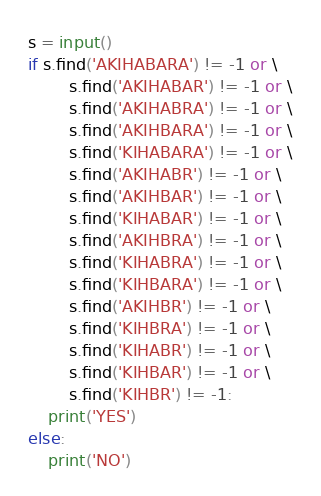<code> <loc_0><loc_0><loc_500><loc_500><_Python_>s = input()
if s.find('AKIHABARA') != -1 or \
        s.find('AKIHABAR') != -1 or \
        s.find('AKIHABRA') != -1 or \
        s.find('AKIHBARA') != -1 or \
        s.find('KIHABARA') != -1 or \
        s.find('AKIHABR') != -1 or \
        s.find('AKIHBAR') != -1 or \
        s.find('KIHABAR') != -1 or \
        s.find('AKIHBRA') != -1 or \
        s.find('KIHABRA') != -1 or \
        s.find('KIHBARA') != -1 or \
        s.find('AKIHBR') != -1 or \
        s.find('KIHBRA') != -1 or \
        s.find('KIHABR') != -1 or \
        s.find('KIHBAR') != -1 or \
        s.find('KIHBR') != -1:
    print('YES')
else:
    print('NO')
</code> 